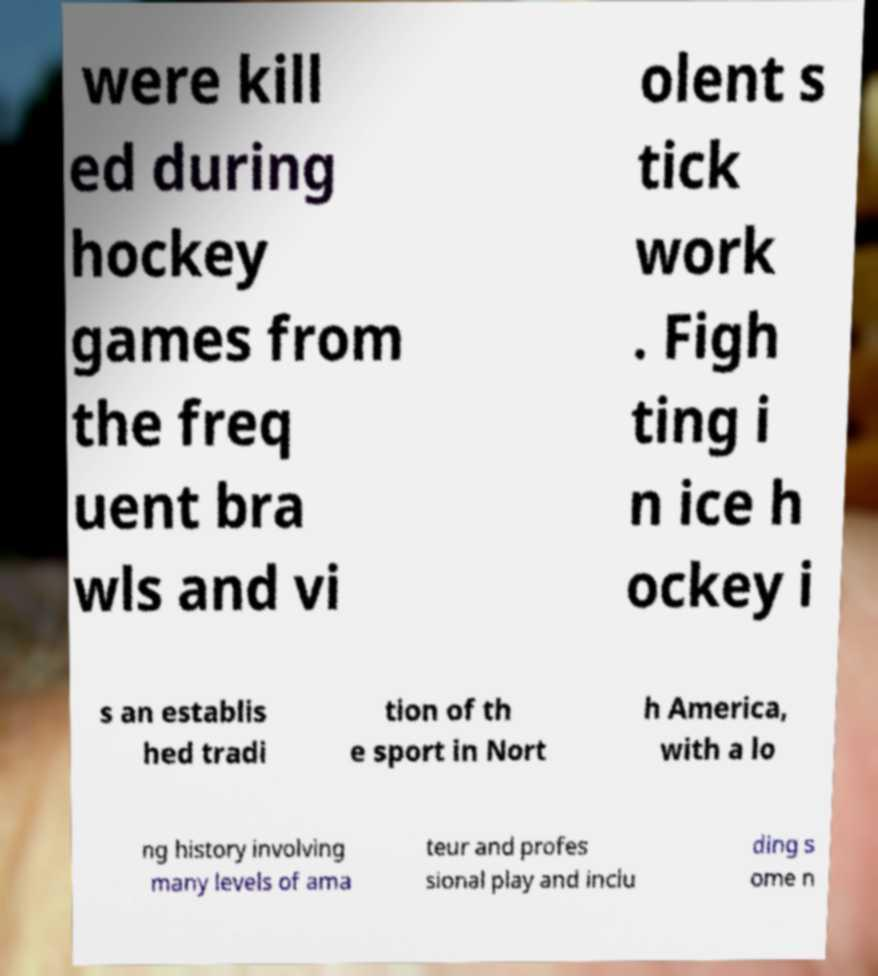Please read and relay the text visible in this image. What does it say? were kill ed during hockey games from the freq uent bra wls and vi olent s tick work . Figh ting i n ice h ockey i s an establis hed tradi tion of th e sport in Nort h America, with a lo ng history involving many levels of ama teur and profes sional play and inclu ding s ome n 